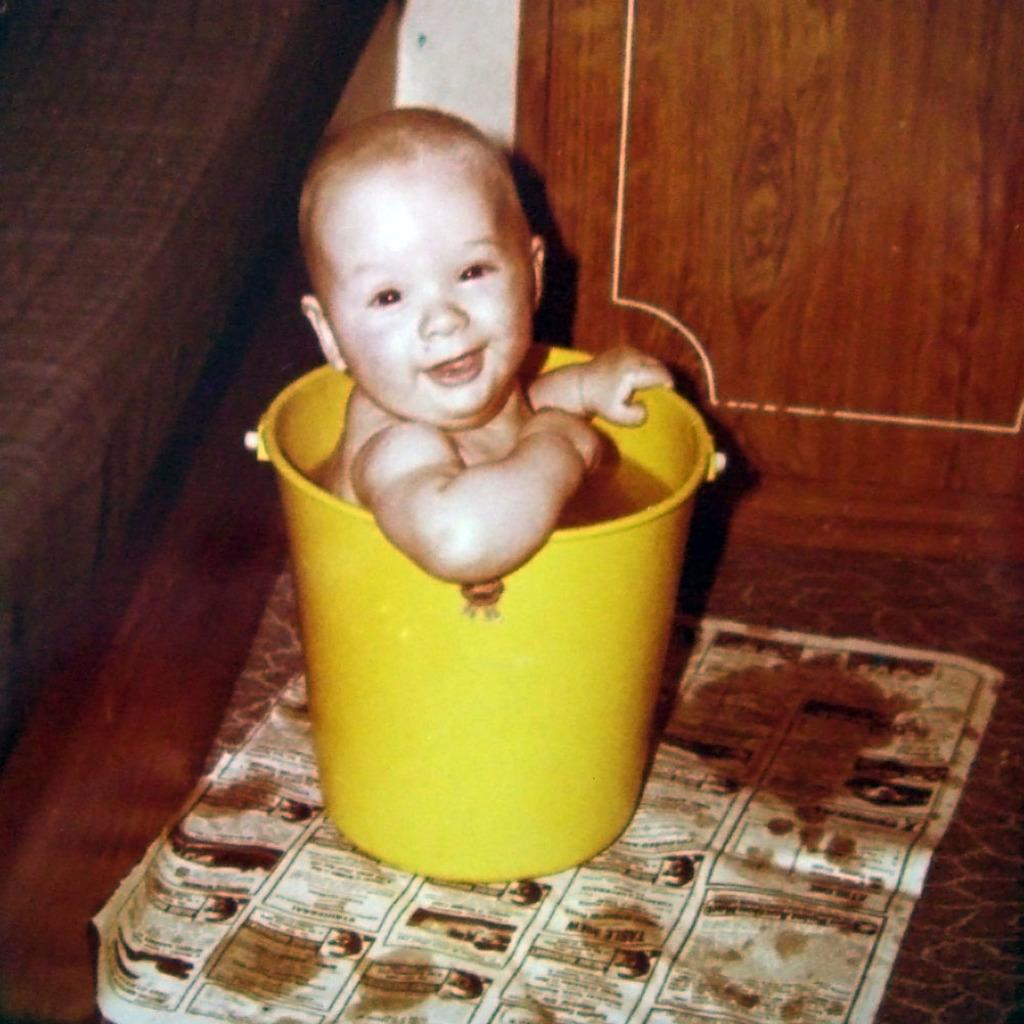What is located in the foreground of the image? There is a bucket in the foreground of the image. What is inside the bucket? A baby is present in the bucket. What is on the floor in the image? There is a paper on the floor. What can be seen in the background of the image? There is a bed and a cupboard in the background of the image. What type of gold ball is the baby playing with in the image? There is no gold ball present in the image; the baby is in a bucket. Can you see any birds in the image? There are no birds visible in the image. 